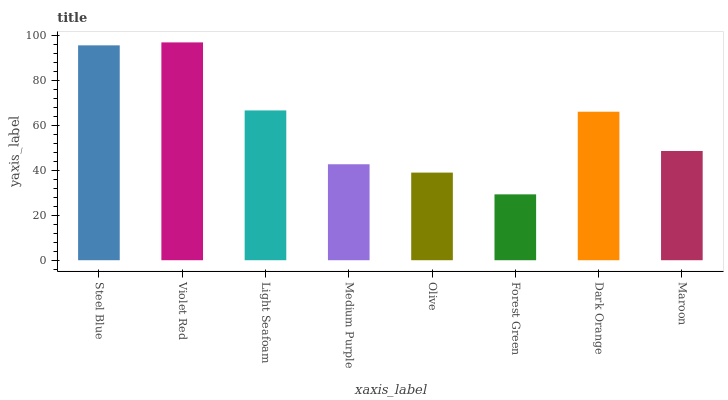Is Forest Green the minimum?
Answer yes or no. Yes. Is Violet Red the maximum?
Answer yes or no. Yes. Is Light Seafoam the minimum?
Answer yes or no. No. Is Light Seafoam the maximum?
Answer yes or no. No. Is Violet Red greater than Light Seafoam?
Answer yes or no. Yes. Is Light Seafoam less than Violet Red?
Answer yes or no. Yes. Is Light Seafoam greater than Violet Red?
Answer yes or no. No. Is Violet Red less than Light Seafoam?
Answer yes or no. No. Is Dark Orange the high median?
Answer yes or no. Yes. Is Maroon the low median?
Answer yes or no. Yes. Is Maroon the high median?
Answer yes or no. No. Is Steel Blue the low median?
Answer yes or no. No. 